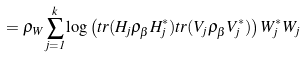Convert formula to latex. <formula><loc_0><loc_0><loc_500><loc_500>= \rho _ { W } \sum _ { j = 1 } ^ { k } \log \left ( t r ( H _ { j } \rho _ { \beta } H _ { j } ^ { * } ) t r ( V _ { j } \rho _ { \beta } V _ { j } ^ { * } ) \right ) W _ { j } ^ { * } W _ { j }</formula> 